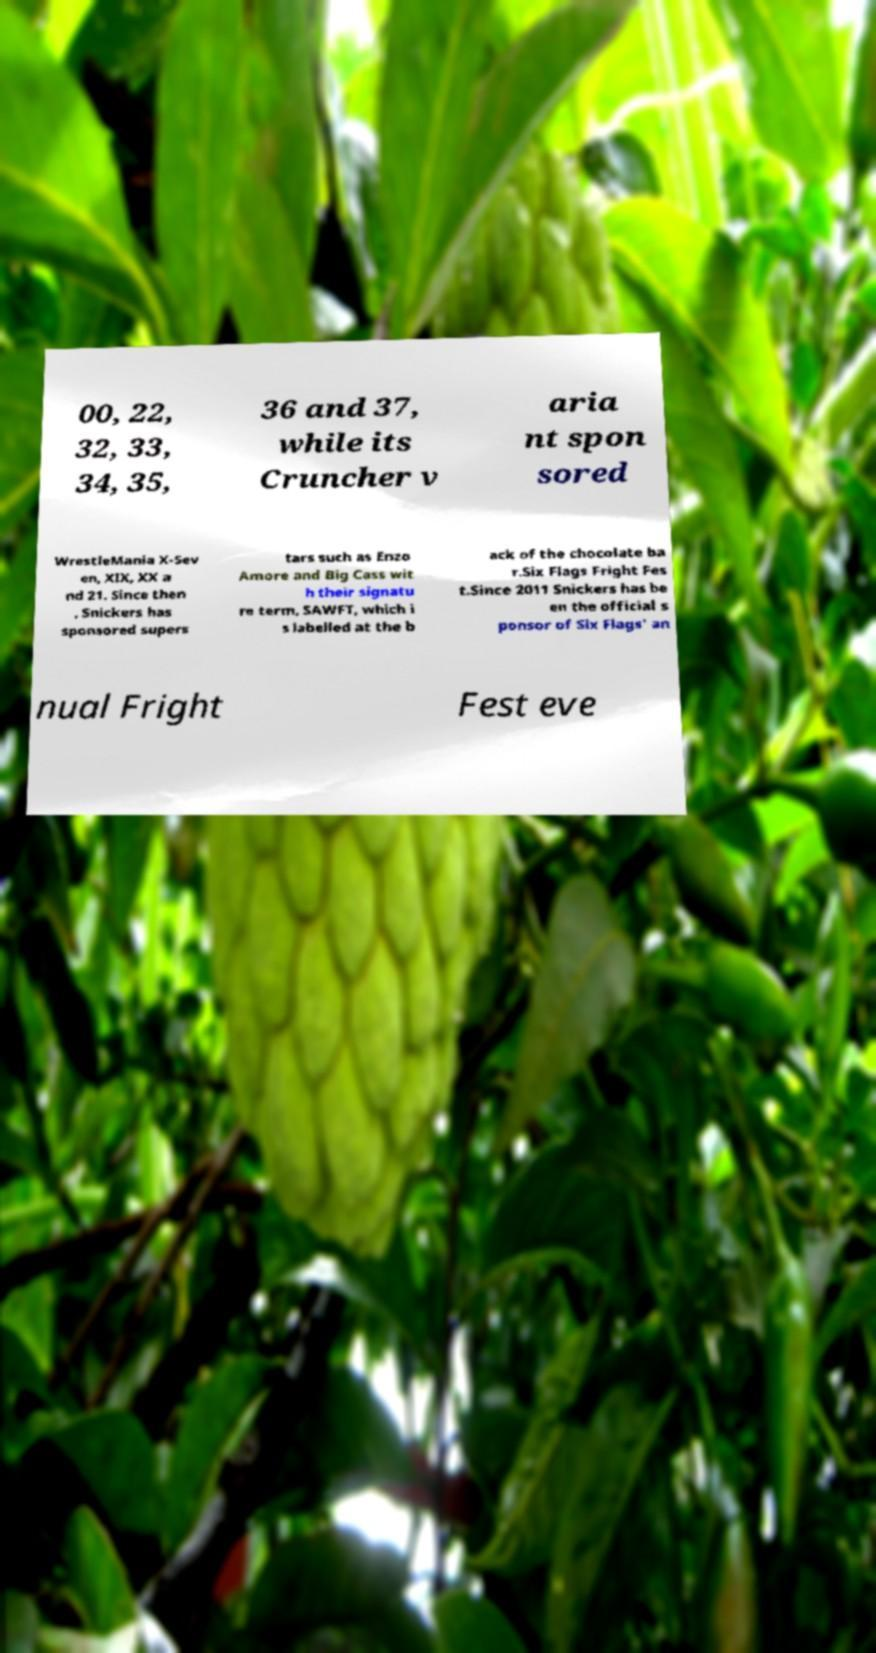Please read and relay the text visible in this image. What does it say? 00, 22, 32, 33, 34, 35, 36 and 37, while its Cruncher v aria nt spon sored WrestleMania X-Sev en, XIX, XX a nd 21. Since then , Snickers has sponsored supers tars such as Enzo Amore and Big Cass wit h their signatu re term, SAWFT, which i s labelled at the b ack of the chocolate ba r.Six Flags Fright Fes t.Since 2011 Snickers has be en the official s ponsor of Six Flags' an nual Fright Fest eve 